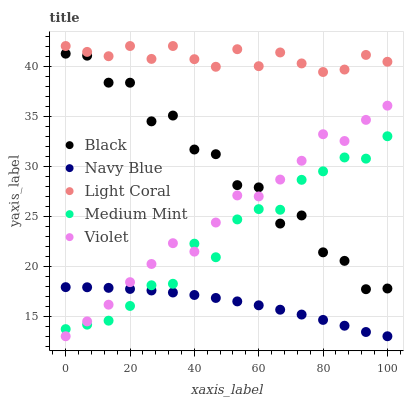Does Navy Blue have the minimum area under the curve?
Answer yes or no. Yes. Does Light Coral have the maximum area under the curve?
Answer yes or no. Yes. Does Violet have the minimum area under the curve?
Answer yes or no. No. Does Violet have the maximum area under the curve?
Answer yes or no. No. Is Navy Blue the smoothest?
Answer yes or no. Yes. Is Black the roughest?
Answer yes or no. Yes. Is Violet the smoothest?
Answer yes or no. No. Is Violet the roughest?
Answer yes or no. No. Does Navy Blue have the lowest value?
Answer yes or no. Yes. Does Black have the lowest value?
Answer yes or no. No. Does Light Coral have the highest value?
Answer yes or no. Yes. Does Violet have the highest value?
Answer yes or no. No. Is Navy Blue less than Light Coral?
Answer yes or no. Yes. Is Light Coral greater than Violet?
Answer yes or no. Yes. Does Black intersect Violet?
Answer yes or no. Yes. Is Black less than Violet?
Answer yes or no. No. Is Black greater than Violet?
Answer yes or no. No. Does Navy Blue intersect Light Coral?
Answer yes or no. No. 